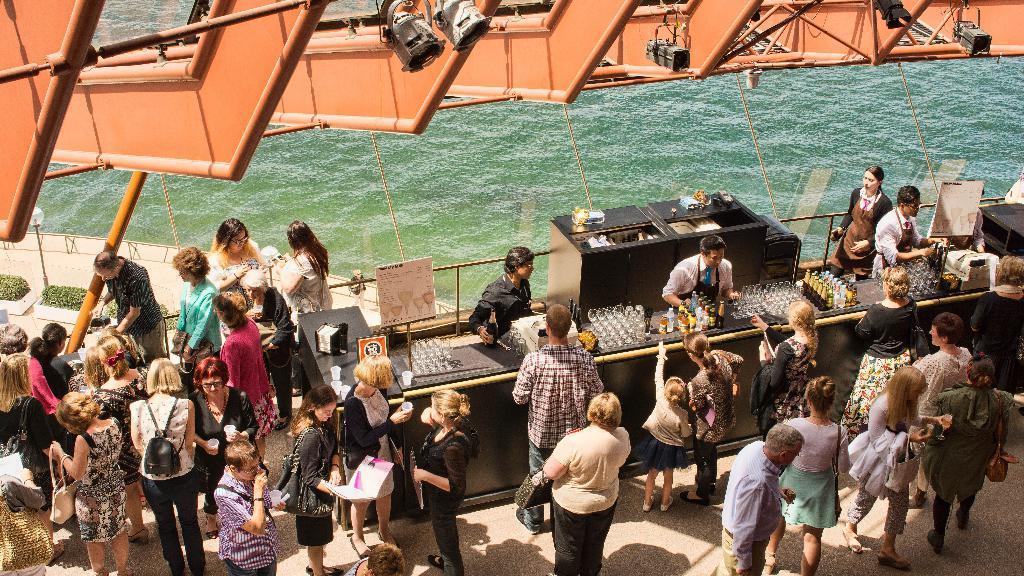Can you describe this image briefly? In this picture I can see group of people standing, there are wine glasses and wine bottles on the table, there are boards, lights, plants and some other objects, and in the background there is water. 